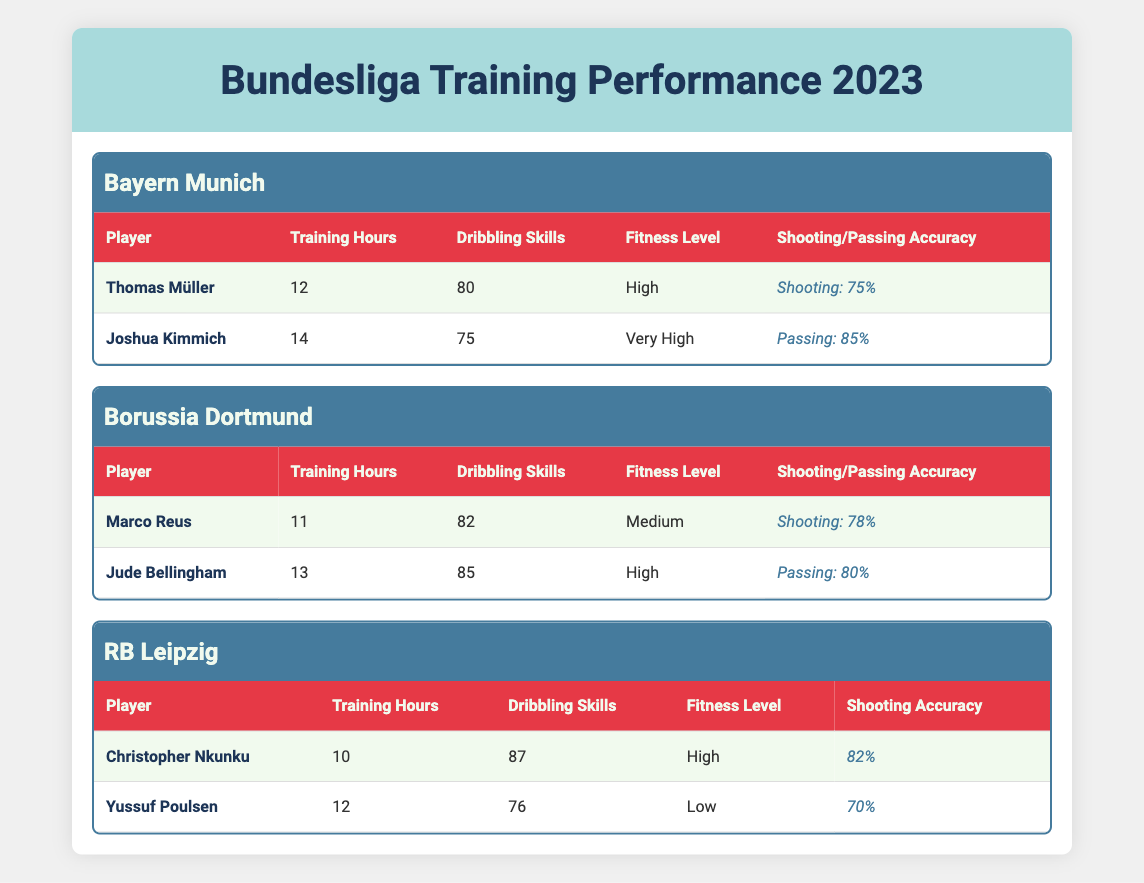What is the shooting accuracy of Thomas Müller? According to the table, Thomas Müller's shooting accuracy is listed as 75%.
Answer: 75% How many training hours did Joshua Kimmich complete? The table shows that Joshua Kimmich completed 14 training hours.
Answer: 14 Which player has the highest dribbling skills? By comparing the dribbling skills of all players, Christopher Nkunku has the highest dribbling skills at 87.
Answer: Christopher Nkunku What is the average number of training hours for players in Bayern Munich? The training hours for Bayern Munich players are 12 (Thomas Müller) and 14 (Joshua Kimmich). The average is (12 + 14) / 2 = 13.
Answer: 13 Is Jude Bellingham's fitness level "Very High"? The table indicates Jude Bellingham's fitness level is "High," not "Very High."
Answer: No What is the combined shooting accuracy of the players in RB Leipzig? The players in RB Leipzig have shooting accuracies of 82% (Christopher Nkunku) and 70% (Yussuf Poulsen). When combined, it sums up to 82 + 70 = 152%.
Answer: 152% Which player from Borussia Dortmund has the highest passing accuracy? Marco Reus has a shooting accuracy of 78%, while Jude Bellingham has a passing accuracy of 80%. Thus, Jude Bellingham has the highest passing accuracy.
Answer: Jude Bellingham What is the difference in training hours between players in Bayern Munich and those in RB Leipzig? Bayern Munich players have 12 and 14 hours respectively, averaging 13. RB Leipzig players have 10 and 12 hours, averaging 11. The difference in averages is 13 - 11 = 2.
Answer: 2 Which fitness level do most players have? The table shows various fitness levels: Bayern Munich has "High" and "Very High," Borussia Dortmund has "Medium" and "High," and RB Leipzig has "High" and "Low." Since "High" occurs three times, it is the most common level.
Answer: High 